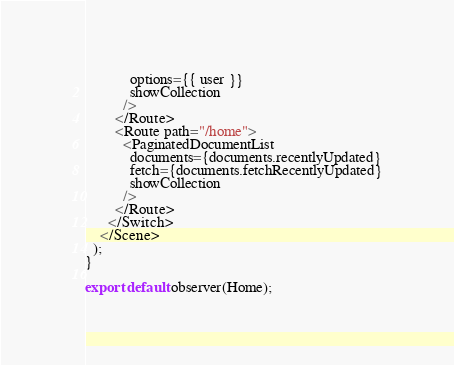Convert code to text. <code><loc_0><loc_0><loc_500><loc_500><_JavaScript_>            options={{ user }}
            showCollection
          />
        </Route>
        <Route path="/home">
          <PaginatedDocumentList
            documents={documents.recentlyUpdated}
            fetch={documents.fetchRecentlyUpdated}
            showCollection
          />
        </Route>
      </Switch>
    </Scene>
  );
}

export default observer(Home);
</code> 